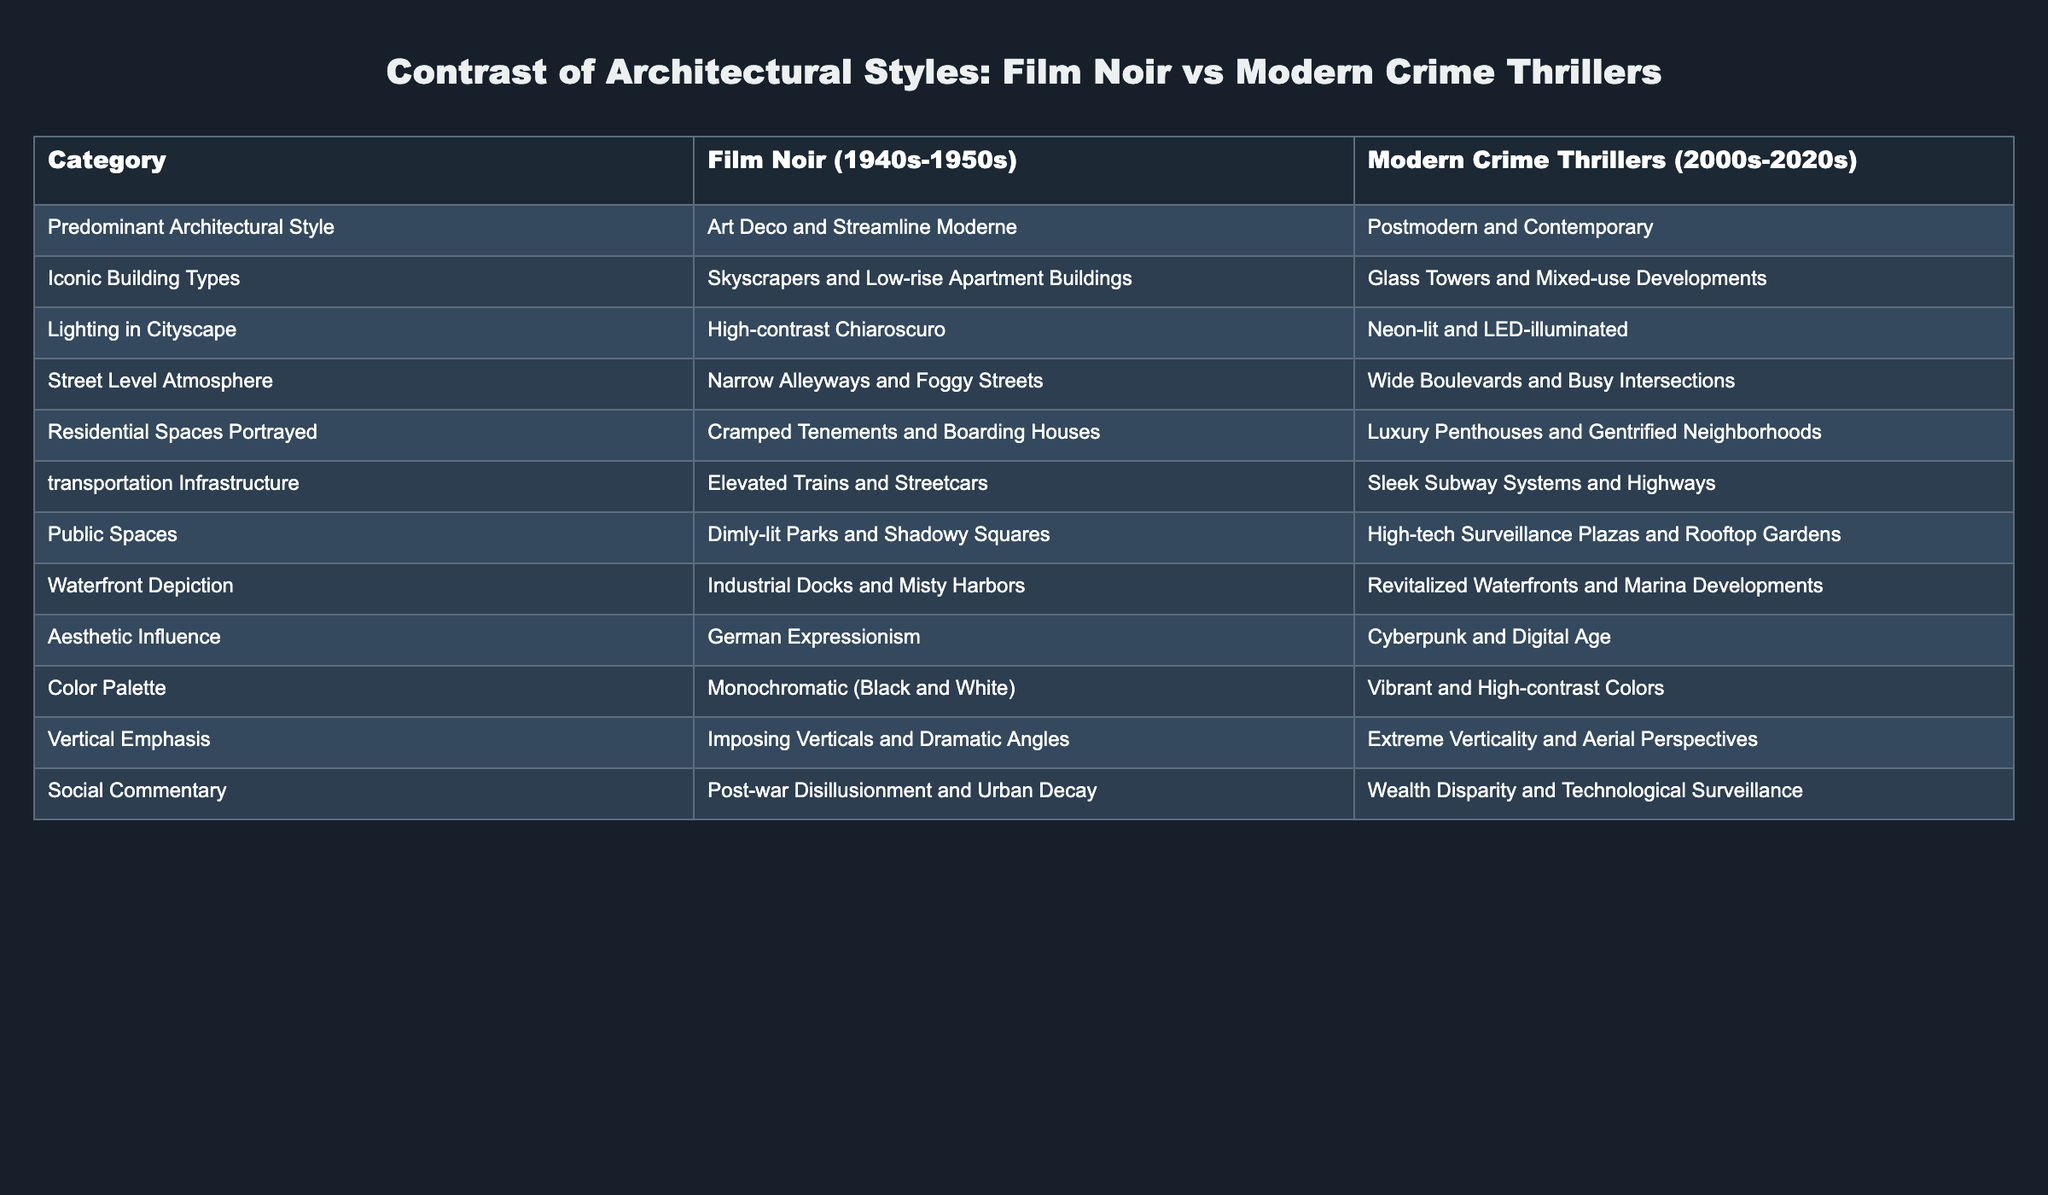What is the predominant architectural style in film noir? The table indicates that the predominant architectural style in film noir is Art Deco and Streamline Moderne, which can be directly referenced from the Film Noir column under the category of Predominant Architectural Style.
Answer: Art Deco and Streamline Moderne How does the transportation infrastructure differ between the two categories? According to the table, film noir features elevated trains and streetcars, while modern crime thrillers showcase sleek subway systems and highways, clearly illustrating a shift in transportation focus.
Answer: Elevated trains and streetcars vs sleek subway systems and highways Is German Expressionism an aesthetic influence in modern crime thrillers? The table indicates that German Expressionism is listed as an aesthetic influence for film noir, while modern crime thrillers are influenced by Cyberpunk and Digital Age; therefore, the answer is no.
Answer: No What is the difference in street-level atmosphere between the two genres? The table shows that film noir is characterized by narrow alleyways and foggy streets, whereas modern crime thrillers have wide boulevards and busy intersections, highlighting contrasting urban environments.
Answer: Narrow alleyways and foggy streets vs wide boulevards and busy intersections What is the average height emphasis across both genres? The table indicates that film noir emphasizes imposing verticals and dramatic angles, while modern crime thrillers emphasize extreme verticality and aerial perspectives. To find an average, consider the two descriptions alongside design intentions, but since these aren't numerical values, a qualitative average comparison would indicate they both emphasize verticality in different styles.
Answer: Both genres emphasize verticality What type of residential spaces are portrayed in film noir compared to modern crime thrillers? Film noir typically portrays cramped tenements and boarding houses, while modern crime thrillers depict luxury penthouses and gentrified neighborhoods. This contrast illustrates the changing socio-economic conditions and architectural trends over time.
Answer: Cramped tenements vs luxury penthouses What kind of social commentary is reflected in modern crime thrillers? The table highlights that modern crime thrillers comment on wealth disparity and technological surveillance, suggesting a focus on contemporary socio-economic issues, as opposed to the post-war disillusionment depicted in film noir.
Answer: Wealth disparity and technological surveillance Which genre depicts industrial docks and misty harbors? Referring to the waterfront depiction in the table, industrial docks and misty harbors are associated with film noir, indicating a more gritty and less developed urban waterfront than the revitalized settings presented in modern crime thrillers.
Answer: Film noir 